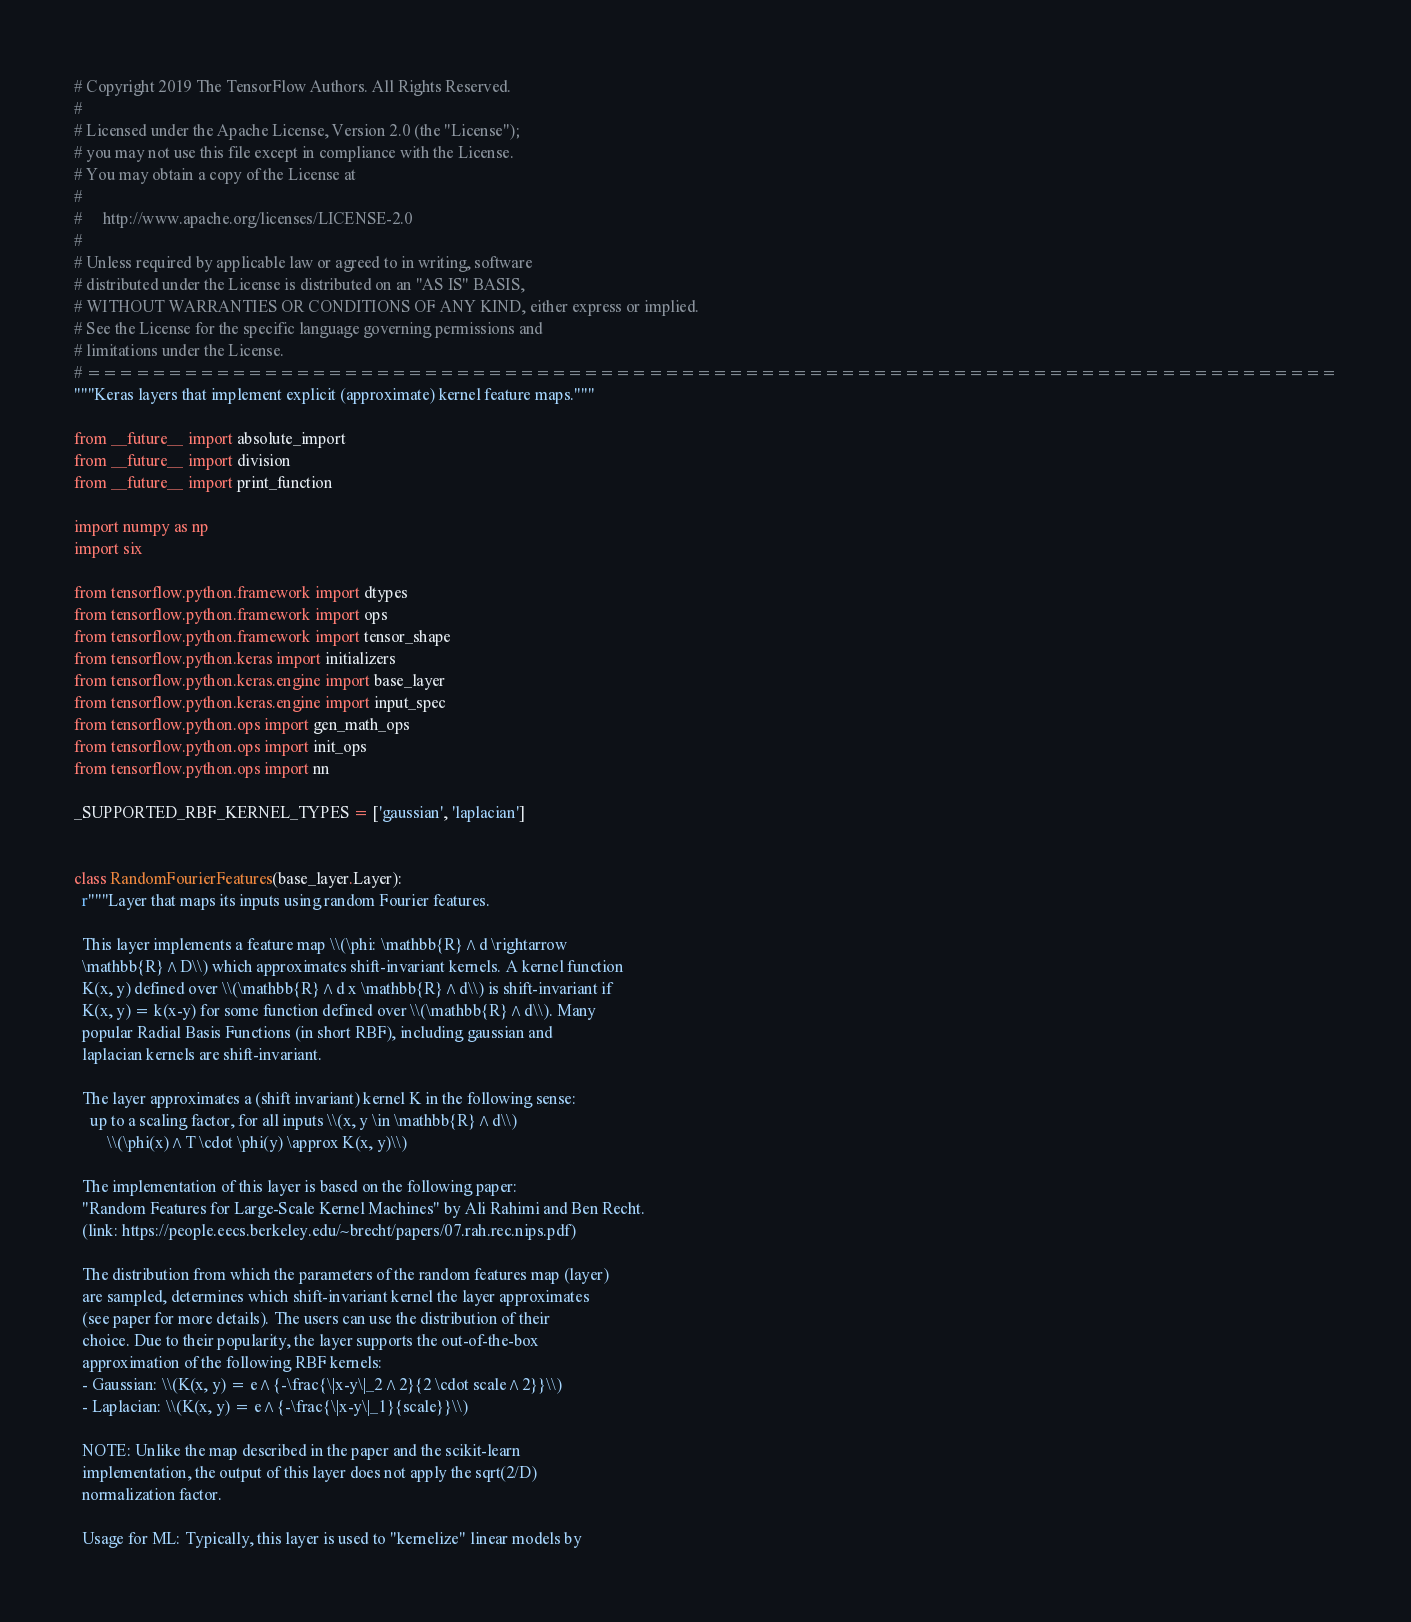<code> <loc_0><loc_0><loc_500><loc_500><_Python_># Copyright 2019 The TensorFlow Authors. All Rights Reserved.
#
# Licensed under the Apache License, Version 2.0 (the "License");
# you may not use this file except in compliance with the License.
# You may obtain a copy of the License at
#
#     http://www.apache.org/licenses/LICENSE-2.0
#
# Unless required by applicable law or agreed to in writing, software
# distributed under the License is distributed on an "AS IS" BASIS,
# WITHOUT WARRANTIES OR CONDITIONS OF ANY KIND, either express or implied.
# See the License for the specific language governing permissions and
# limitations under the License.
# ==============================================================================
"""Keras layers that implement explicit (approximate) kernel feature maps."""

from __future__ import absolute_import
from __future__ import division
from __future__ import print_function

import numpy as np
import six

from tensorflow.python.framework import dtypes
from tensorflow.python.framework import ops
from tensorflow.python.framework import tensor_shape
from tensorflow.python.keras import initializers
from tensorflow.python.keras.engine import base_layer
from tensorflow.python.keras.engine import input_spec
from tensorflow.python.ops import gen_math_ops
from tensorflow.python.ops import init_ops
from tensorflow.python.ops import nn

_SUPPORTED_RBF_KERNEL_TYPES = ['gaussian', 'laplacian']


class RandomFourierFeatures(base_layer.Layer):
  r"""Layer that maps its inputs using random Fourier features.

  This layer implements a feature map \\(\phi: \mathbb{R}^d \rightarrow
  \mathbb{R}^D\\) which approximates shift-invariant kernels. A kernel function
  K(x, y) defined over \\(\mathbb{R}^d x \mathbb{R}^d\\) is shift-invariant if
  K(x, y) = k(x-y) for some function defined over \\(\mathbb{R}^d\\). Many
  popular Radial Basis Functions (in short RBF), including gaussian and
  laplacian kernels are shift-invariant.

  The layer approximates a (shift invariant) kernel K in the following sense:
    up to a scaling factor, for all inputs \\(x, y \in \mathbb{R}^d\\)
        \\(\phi(x)^T \cdot \phi(y) \approx K(x, y)\\)

  The implementation of this layer is based on the following paper:
  "Random Features for Large-Scale Kernel Machines" by Ali Rahimi and Ben Recht.
  (link: https://people.eecs.berkeley.edu/~brecht/papers/07.rah.rec.nips.pdf)

  The distribution from which the parameters of the random features map (layer)
  are sampled, determines which shift-invariant kernel the layer approximates
  (see paper for more details). The users can use the distribution of their
  choice. Due to their popularity, the layer supports the out-of-the-box
  approximation of the following RBF kernels:
  - Gaussian: \\(K(x, y) = e^{-\frac{\|x-y\|_2^2}{2 \cdot scale^2}}\\)
  - Laplacian: \\(K(x, y) = e^{-\frac{\|x-y\|_1}{scale}}\\)

  NOTE: Unlike the map described in the paper and the scikit-learn
  implementation, the output of this layer does not apply the sqrt(2/D)
  normalization factor.

  Usage for ML: Typically, this layer is used to "kernelize" linear models by</code> 